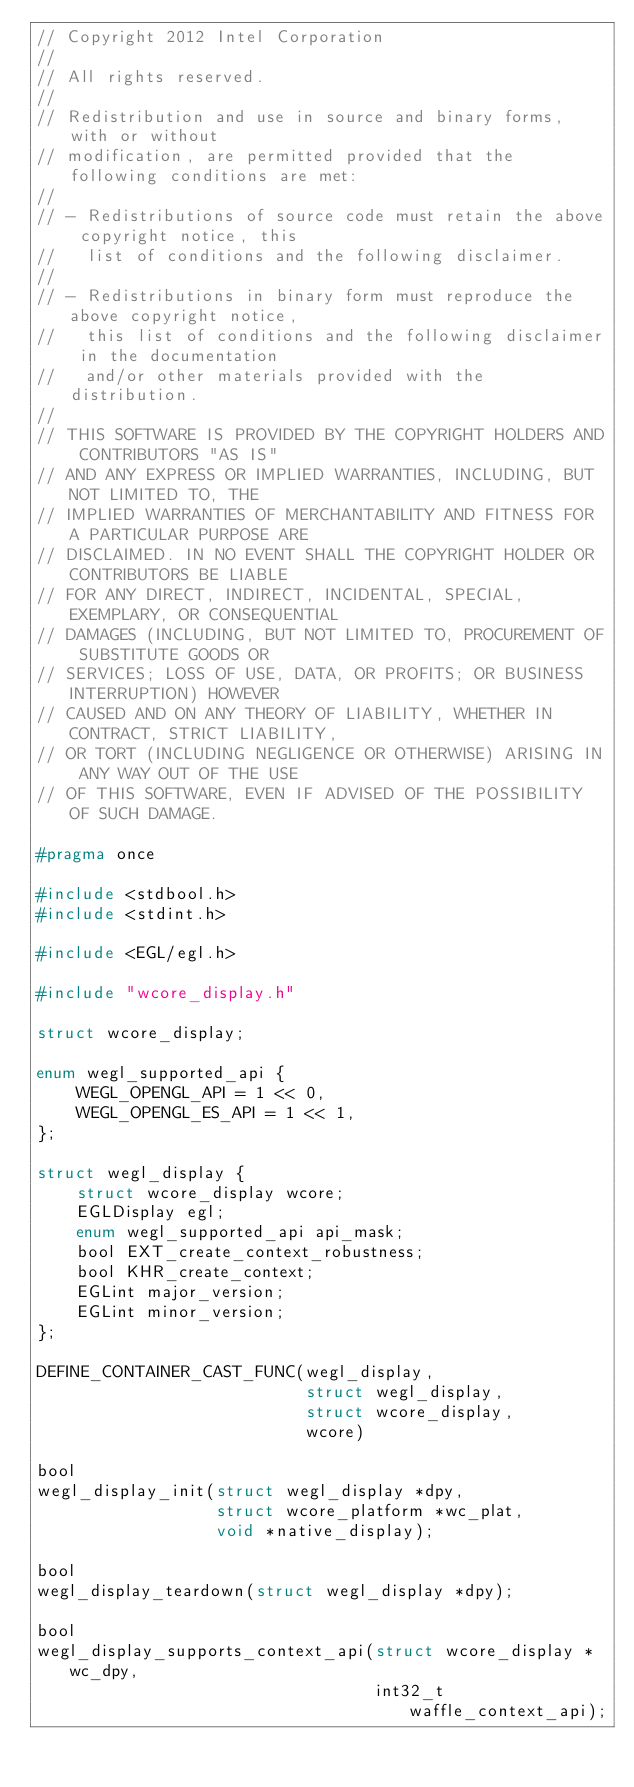<code> <loc_0><loc_0><loc_500><loc_500><_C_>// Copyright 2012 Intel Corporation
//
// All rights reserved.
//
// Redistribution and use in source and binary forms, with or without
// modification, are permitted provided that the following conditions are met:
//
// - Redistributions of source code must retain the above copyright notice, this
//   list of conditions and the following disclaimer.
//
// - Redistributions in binary form must reproduce the above copyright notice,
//   this list of conditions and the following disclaimer in the documentation
//   and/or other materials provided with the distribution.
//
// THIS SOFTWARE IS PROVIDED BY THE COPYRIGHT HOLDERS AND CONTRIBUTORS "AS IS"
// AND ANY EXPRESS OR IMPLIED WARRANTIES, INCLUDING, BUT NOT LIMITED TO, THE
// IMPLIED WARRANTIES OF MERCHANTABILITY AND FITNESS FOR A PARTICULAR PURPOSE ARE
// DISCLAIMED. IN NO EVENT SHALL THE COPYRIGHT HOLDER OR CONTRIBUTORS BE LIABLE
// FOR ANY DIRECT, INDIRECT, INCIDENTAL, SPECIAL, EXEMPLARY, OR CONSEQUENTIAL
// DAMAGES (INCLUDING, BUT NOT LIMITED TO, PROCUREMENT OF SUBSTITUTE GOODS OR
// SERVICES; LOSS OF USE, DATA, OR PROFITS; OR BUSINESS INTERRUPTION) HOWEVER
// CAUSED AND ON ANY THEORY OF LIABILITY, WHETHER IN CONTRACT, STRICT LIABILITY,
// OR TORT (INCLUDING NEGLIGENCE OR OTHERWISE) ARISING IN ANY WAY OUT OF THE USE
// OF THIS SOFTWARE, EVEN IF ADVISED OF THE POSSIBILITY OF SUCH DAMAGE.

#pragma once

#include <stdbool.h>
#include <stdint.h>

#include <EGL/egl.h>

#include "wcore_display.h"

struct wcore_display;

enum wegl_supported_api {
    WEGL_OPENGL_API = 1 << 0,
    WEGL_OPENGL_ES_API = 1 << 1,
};

struct wegl_display {
    struct wcore_display wcore;
    EGLDisplay egl;
    enum wegl_supported_api api_mask;
    bool EXT_create_context_robustness;
    bool KHR_create_context;
    EGLint major_version;
    EGLint minor_version;
};

DEFINE_CONTAINER_CAST_FUNC(wegl_display,
                           struct wegl_display,
                           struct wcore_display,
                           wcore)

bool
wegl_display_init(struct wegl_display *dpy,
                  struct wcore_platform *wc_plat,
                  void *native_display);

bool
wegl_display_teardown(struct wegl_display *dpy);

bool
wegl_display_supports_context_api(struct wcore_display *wc_dpy,
                                  int32_t waffle_context_api);
</code> 